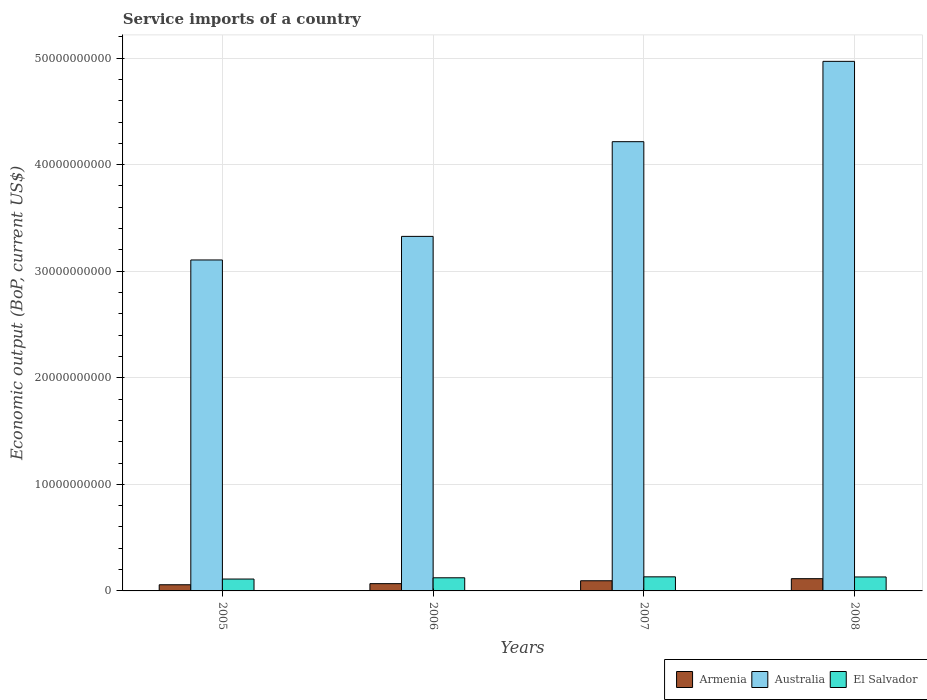How many different coloured bars are there?
Ensure brevity in your answer.  3. How many groups of bars are there?
Your answer should be very brief. 4. Are the number of bars per tick equal to the number of legend labels?
Provide a short and direct response. Yes. How many bars are there on the 2nd tick from the left?
Offer a very short reply. 3. How many bars are there on the 2nd tick from the right?
Ensure brevity in your answer.  3. What is the service imports in Armenia in 2007?
Your answer should be very brief. 9.54e+08. Across all years, what is the maximum service imports in Australia?
Provide a short and direct response. 4.97e+1. Across all years, what is the minimum service imports in Australia?
Offer a terse response. 3.11e+1. In which year was the service imports in Australia minimum?
Your response must be concise. 2005. What is the total service imports in Australia in the graph?
Ensure brevity in your answer.  1.56e+11. What is the difference between the service imports in El Salvador in 2006 and that in 2007?
Provide a succinct answer. -8.94e+07. What is the difference between the service imports in Australia in 2005 and the service imports in El Salvador in 2006?
Provide a short and direct response. 2.98e+1. What is the average service imports in Armenia per year?
Offer a very short reply. 8.41e+08. In the year 2008, what is the difference between the service imports in Armenia and service imports in El Salvador?
Provide a succinct answer. -1.62e+08. In how many years, is the service imports in Armenia greater than 4000000000 US$?
Your response must be concise. 0. What is the ratio of the service imports in Armenia in 2007 to that in 2008?
Your answer should be compact. 0.83. Is the service imports in Australia in 2005 less than that in 2006?
Offer a very short reply. Yes. What is the difference between the highest and the second highest service imports in Armenia?
Give a very brief answer. 1.94e+08. What is the difference between the highest and the lowest service imports in El Salvador?
Your answer should be compact. 2.07e+08. In how many years, is the service imports in El Salvador greater than the average service imports in El Salvador taken over all years?
Your response must be concise. 2. Is the sum of the service imports in El Salvador in 2005 and 2007 greater than the maximum service imports in Australia across all years?
Your answer should be very brief. No. What does the 3rd bar from the left in 2007 represents?
Your answer should be very brief. El Salvador. What does the 1st bar from the right in 2008 represents?
Give a very brief answer. El Salvador. Is it the case that in every year, the sum of the service imports in Armenia and service imports in Australia is greater than the service imports in El Salvador?
Your answer should be very brief. Yes. Are the values on the major ticks of Y-axis written in scientific E-notation?
Provide a succinct answer. No. Does the graph contain grids?
Provide a succinct answer. Yes. Where does the legend appear in the graph?
Provide a short and direct response. Bottom right. What is the title of the graph?
Your answer should be very brief. Service imports of a country. What is the label or title of the Y-axis?
Your answer should be very brief. Economic output (BoP, current US$). What is the Economic output (BoP, current US$) of Armenia in 2005?
Provide a short and direct response. 5.78e+08. What is the Economic output (BoP, current US$) of Australia in 2005?
Provide a short and direct response. 3.11e+1. What is the Economic output (BoP, current US$) in El Salvador in 2005?
Your answer should be compact. 1.11e+09. What is the Economic output (BoP, current US$) of Armenia in 2006?
Offer a terse response. 6.82e+08. What is the Economic output (BoP, current US$) in Australia in 2006?
Make the answer very short. 3.33e+1. What is the Economic output (BoP, current US$) in El Salvador in 2006?
Give a very brief answer. 1.23e+09. What is the Economic output (BoP, current US$) of Armenia in 2007?
Provide a succinct answer. 9.54e+08. What is the Economic output (BoP, current US$) in Australia in 2007?
Give a very brief answer. 4.22e+1. What is the Economic output (BoP, current US$) in El Salvador in 2007?
Your response must be concise. 1.32e+09. What is the Economic output (BoP, current US$) of Armenia in 2008?
Provide a succinct answer. 1.15e+09. What is the Economic output (BoP, current US$) of Australia in 2008?
Your response must be concise. 4.97e+1. What is the Economic output (BoP, current US$) in El Salvador in 2008?
Your answer should be very brief. 1.31e+09. Across all years, what is the maximum Economic output (BoP, current US$) of Armenia?
Provide a succinct answer. 1.15e+09. Across all years, what is the maximum Economic output (BoP, current US$) of Australia?
Ensure brevity in your answer.  4.97e+1. Across all years, what is the maximum Economic output (BoP, current US$) of El Salvador?
Your answer should be very brief. 1.32e+09. Across all years, what is the minimum Economic output (BoP, current US$) of Armenia?
Your response must be concise. 5.78e+08. Across all years, what is the minimum Economic output (BoP, current US$) in Australia?
Your answer should be very brief. 3.11e+1. Across all years, what is the minimum Economic output (BoP, current US$) of El Salvador?
Keep it short and to the point. 1.11e+09. What is the total Economic output (BoP, current US$) in Armenia in the graph?
Keep it short and to the point. 3.36e+09. What is the total Economic output (BoP, current US$) of Australia in the graph?
Make the answer very short. 1.56e+11. What is the total Economic output (BoP, current US$) of El Salvador in the graph?
Your answer should be compact. 4.98e+09. What is the difference between the Economic output (BoP, current US$) in Armenia in 2005 and that in 2006?
Your answer should be very brief. -1.04e+08. What is the difference between the Economic output (BoP, current US$) in Australia in 2005 and that in 2006?
Provide a short and direct response. -2.21e+09. What is the difference between the Economic output (BoP, current US$) in El Salvador in 2005 and that in 2006?
Your answer should be very brief. -1.17e+08. What is the difference between the Economic output (BoP, current US$) of Armenia in 2005 and that in 2007?
Your answer should be compact. -3.76e+08. What is the difference between the Economic output (BoP, current US$) of Australia in 2005 and that in 2007?
Make the answer very short. -1.11e+1. What is the difference between the Economic output (BoP, current US$) in El Salvador in 2005 and that in 2007?
Your answer should be compact. -2.07e+08. What is the difference between the Economic output (BoP, current US$) of Armenia in 2005 and that in 2008?
Your response must be concise. -5.70e+08. What is the difference between the Economic output (BoP, current US$) in Australia in 2005 and that in 2008?
Provide a succinct answer. -1.86e+1. What is the difference between the Economic output (BoP, current US$) in El Salvador in 2005 and that in 2008?
Provide a short and direct response. -1.96e+08. What is the difference between the Economic output (BoP, current US$) of Armenia in 2006 and that in 2007?
Your response must be concise. -2.72e+08. What is the difference between the Economic output (BoP, current US$) in Australia in 2006 and that in 2007?
Offer a terse response. -8.89e+09. What is the difference between the Economic output (BoP, current US$) in El Salvador in 2006 and that in 2007?
Your answer should be very brief. -8.94e+07. What is the difference between the Economic output (BoP, current US$) in Armenia in 2006 and that in 2008?
Your response must be concise. -4.66e+08. What is the difference between the Economic output (BoP, current US$) of Australia in 2006 and that in 2008?
Give a very brief answer. -1.64e+1. What is the difference between the Economic output (BoP, current US$) in El Salvador in 2006 and that in 2008?
Make the answer very short. -7.88e+07. What is the difference between the Economic output (BoP, current US$) in Armenia in 2007 and that in 2008?
Give a very brief answer. -1.94e+08. What is the difference between the Economic output (BoP, current US$) in Australia in 2007 and that in 2008?
Your response must be concise. -7.54e+09. What is the difference between the Economic output (BoP, current US$) of El Salvador in 2007 and that in 2008?
Your answer should be compact. 1.06e+07. What is the difference between the Economic output (BoP, current US$) of Armenia in 2005 and the Economic output (BoP, current US$) of Australia in 2006?
Your answer should be very brief. -3.27e+1. What is the difference between the Economic output (BoP, current US$) in Armenia in 2005 and the Economic output (BoP, current US$) in El Salvador in 2006?
Provide a succinct answer. -6.54e+08. What is the difference between the Economic output (BoP, current US$) of Australia in 2005 and the Economic output (BoP, current US$) of El Salvador in 2006?
Your response must be concise. 2.98e+1. What is the difference between the Economic output (BoP, current US$) of Armenia in 2005 and the Economic output (BoP, current US$) of Australia in 2007?
Your answer should be very brief. -4.16e+1. What is the difference between the Economic output (BoP, current US$) in Armenia in 2005 and the Economic output (BoP, current US$) in El Salvador in 2007?
Your answer should be very brief. -7.43e+08. What is the difference between the Economic output (BoP, current US$) in Australia in 2005 and the Economic output (BoP, current US$) in El Salvador in 2007?
Offer a very short reply. 2.97e+1. What is the difference between the Economic output (BoP, current US$) in Armenia in 2005 and the Economic output (BoP, current US$) in Australia in 2008?
Your response must be concise. -4.91e+1. What is the difference between the Economic output (BoP, current US$) in Armenia in 2005 and the Economic output (BoP, current US$) in El Salvador in 2008?
Provide a succinct answer. -7.33e+08. What is the difference between the Economic output (BoP, current US$) in Australia in 2005 and the Economic output (BoP, current US$) in El Salvador in 2008?
Your answer should be very brief. 2.97e+1. What is the difference between the Economic output (BoP, current US$) in Armenia in 2006 and the Economic output (BoP, current US$) in Australia in 2007?
Make the answer very short. -4.15e+1. What is the difference between the Economic output (BoP, current US$) in Armenia in 2006 and the Economic output (BoP, current US$) in El Salvador in 2007?
Provide a short and direct response. -6.39e+08. What is the difference between the Economic output (BoP, current US$) of Australia in 2006 and the Economic output (BoP, current US$) of El Salvador in 2007?
Provide a succinct answer. 3.19e+1. What is the difference between the Economic output (BoP, current US$) in Armenia in 2006 and the Economic output (BoP, current US$) in Australia in 2008?
Your answer should be compact. -4.90e+1. What is the difference between the Economic output (BoP, current US$) of Armenia in 2006 and the Economic output (BoP, current US$) of El Salvador in 2008?
Ensure brevity in your answer.  -6.29e+08. What is the difference between the Economic output (BoP, current US$) in Australia in 2006 and the Economic output (BoP, current US$) in El Salvador in 2008?
Your response must be concise. 3.20e+1. What is the difference between the Economic output (BoP, current US$) of Armenia in 2007 and the Economic output (BoP, current US$) of Australia in 2008?
Your response must be concise. -4.87e+1. What is the difference between the Economic output (BoP, current US$) in Armenia in 2007 and the Economic output (BoP, current US$) in El Salvador in 2008?
Provide a succinct answer. -3.56e+08. What is the difference between the Economic output (BoP, current US$) in Australia in 2007 and the Economic output (BoP, current US$) in El Salvador in 2008?
Offer a very short reply. 4.08e+1. What is the average Economic output (BoP, current US$) in Armenia per year?
Provide a succinct answer. 8.41e+08. What is the average Economic output (BoP, current US$) in Australia per year?
Ensure brevity in your answer.  3.90e+1. What is the average Economic output (BoP, current US$) of El Salvador per year?
Keep it short and to the point. 1.24e+09. In the year 2005, what is the difference between the Economic output (BoP, current US$) of Armenia and Economic output (BoP, current US$) of Australia?
Your answer should be compact. -3.05e+1. In the year 2005, what is the difference between the Economic output (BoP, current US$) in Armenia and Economic output (BoP, current US$) in El Salvador?
Give a very brief answer. -5.37e+08. In the year 2005, what is the difference between the Economic output (BoP, current US$) in Australia and Economic output (BoP, current US$) in El Salvador?
Offer a very short reply. 2.99e+1. In the year 2006, what is the difference between the Economic output (BoP, current US$) in Armenia and Economic output (BoP, current US$) in Australia?
Provide a short and direct response. -3.26e+1. In the year 2006, what is the difference between the Economic output (BoP, current US$) in Armenia and Economic output (BoP, current US$) in El Salvador?
Make the answer very short. -5.50e+08. In the year 2006, what is the difference between the Economic output (BoP, current US$) in Australia and Economic output (BoP, current US$) in El Salvador?
Provide a short and direct response. 3.20e+1. In the year 2007, what is the difference between the Economic output (BoP, current US$) in Armenia and Economic output (BoP, current US$) in Australia?
Keep it short and to the point. -4.12e+1. In the year 2007, what is the difference between the Economic output (BoP, current US$) of Armenia and Economic output (BoP, current US$) of El Salvador?
Provide a succinct answer. -3.67e+08. In the year 2007, what is the difference between the Economic output (BoP, current US$) of Australia and Economic output (BoP, current US$) of El Salvador?
Provide a short and direct response. 4.08e+1. In the year 2008, what is the difference between the Economic output (BoP, current US$) in Armenia and Economic output (BoP, current US$) in Australia?
Provide a short and direct response. -4.85e+1. In the year 2008, what is the difference between the Economic output (BoP, current US$) of Armenia and Economic output (BoP, current US$) of El Salvador?
Your answer should be very brief. -1.62e+08. In the year 2008, what is the difference between the Economic output (BoP, current US$) in Australia and Economic output (BoP, current US$) in El Salvador?
Your answer should be compact. 4.84e+1. What is the ratio of the Economic output (BoP, current US$) in Armenia in 2005 to that in 2006?
Ensure brevity in your answer.  0.85. What is the ratio of the Economic output (BoP, current US$) in Australia in 2005 to that in 2006?
Your response must be concise. 0.93. What is the ratio of the Economic output (BoP, current US$) in El Salvador in 2005 to that in 2006?
Offer a very short reply. 0.9. What is the ratio of the Economic output (BoP, current US$) in Armenia in 2005 to that in 2007?
Ensure brevity in your answer.  0.61. What is the ratio of the Economic output (BoP, current US$) of Australia in 2005 to that in 2007?
Your response must be concise. 0.74. What is the ratio of the Economic output (BoP, current US$) in El Salvador in 2005 to that in 2007?
Your response must be concise. 0.84. What is the ratio of the Economic output (BoP, current US$) of Armenia in 2005 to that in 2008?
Your answer should be very brief. 0.5. What is the ratio of the Economic output (BoP, current US$) in Australia in 2005 to that in 2008?
Ensure brevity in your answer.  0.62. What is the ratio of the Economic output (BoP, current US$) of El Salvador in 2005 to that in 2008?
Ensure brevity in your answer.  0.85. What is the ratio of the Economic output (BoP, current US$) of Armenia in 2006 to that in 2007?
Provide a succinct answer. 0.71. What is the ratio of the Economic output (BoP, current US$) of Australia in 2006 to that in 2007?
Your answer should be very brief. 0.79. What is the ratio of the Economic output (BoP, current US$) in El Salvador in 2006 to that in 2007?
Keep it short and to the point. 0.93. What is the ratio of the Economic output (BoP, current US$) of Armenia in 2006 to that in 2008?
Offer a terse response. 0.59. What is the ratio of the Economic output (BoP, current US$) in Australia in 2006 to that in 2008?
Your answer should be very brief. 0.67. What is the ratio of the Economic output (BoP, current US$) in El Salvador in 2006 to that in 2008?
Ensure brevity in your answer.  0.94. What is the ratio of the Economic output (BoP, current US$) in Armenia in 2007 to that in 2008?
Offer a very short reply. 0.83. What is the ratio of the Economic output (BoP, current US$) in Australia in 2007 to that in 2008?
Offer a very short reply. 0.85. What is the ratio of the Economic output (BoP, current US$) of El Salvador in 2007 to that in 2008?
Give a very brief answer. 1.01. What is the difference between the highest and the second highest Economic output (BoP, current US$) of Armenia?
Provide a succinct answer. 1.94e+08. What is the difference between the highest and the second highest Economic output (BoP, current US$) in Australia?
Your answer should be very brief. 7.54e+09. What is the difference between the highest and the second highest Economic output (BoP, current US$) of El Salvador?
Provide a succinct answer. 1.06e+07. What is the difference between the highest and the lowest Economic output (BoP, current US$) of Armenia?
Offer a very short reply. 5.70e+08. What is the difference between the highest and the lowest Economic output (BoP, current US$) in Australia?
Provide a succinct answer. 1.86e+1. What is the difference between the highest and the lowest Economic output (BoP, current US$) of El Salvador?
Provide a short and direct response. 2.07e+08. 